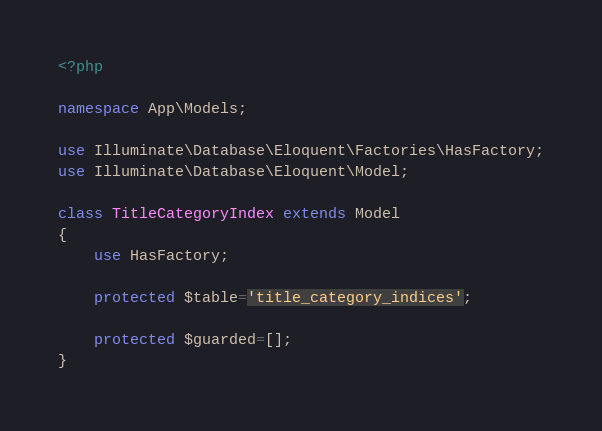<code> <loc_0><loc_0><loc_500><loc_500><_PHP_><?php

namespace App\Models;

use Illuminate\Database\Eloquent\Factories\HasFactory;
use Illuminate\Database\Eloquent\Model;

class TitleCategoryIndex extends Model
{
    use HasFactory;

    protected $table='title_category_indices';

    protected $guarded=[];
}
</code> 